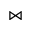<formula> <loc_0><loc_0><loc_500><loc_500>\ J o i n</formula> 